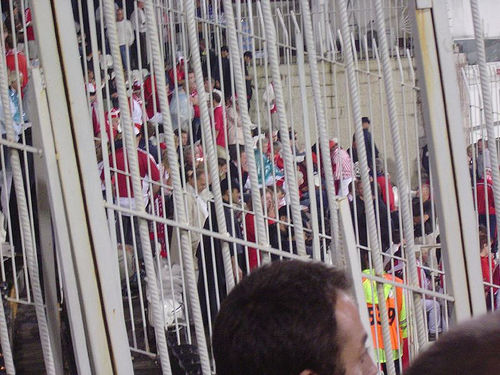<image>
Is the orange vest on the man? No. The orange vest is not positioned on the man. They may be near each other, but the orange vest is not supported by or resting on top of the man. 